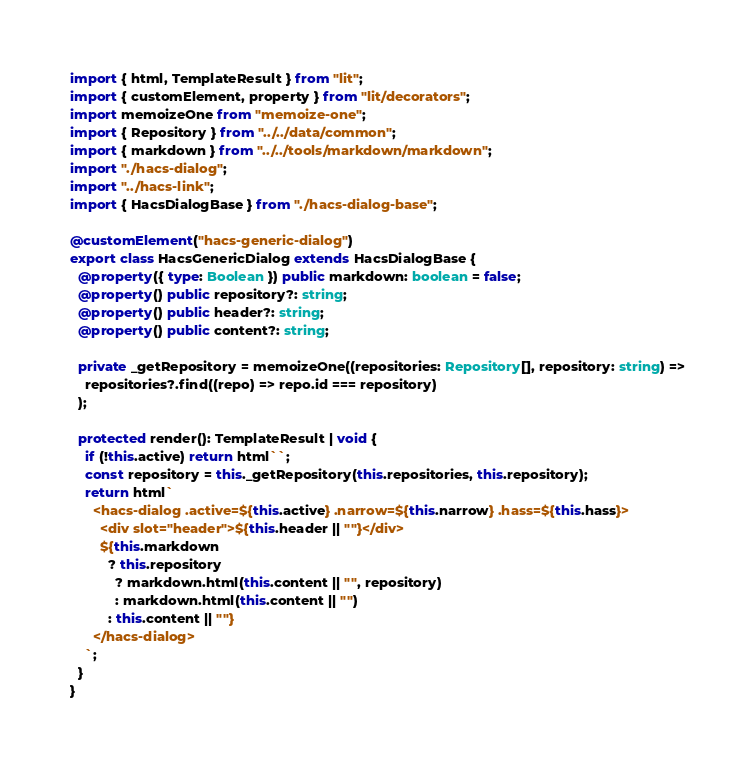<code> <loc_0><loc_0><loc_500><loc_500><_TypeScript_>import { html, TemplateResult } from "lit";
import { customElement, property } from "lit/decorators";
import memoizeOne from "memoize-one";
import { Repository } from "../../data/common";
import { markdown } from "../../tools/markdown/markdown";
import "./hacs-dialog";
import "../hacs-link";
import { HacsDialogBase } from "./hacs-dialog-base";

@customElement("hacs-generic-dialog")
export class HacsGenericDialog extends HacsDialogBase {
  @property({ type: Boolean }) public markdown: boolean = false;
  @property() public repository?: string;
  @property() public header?: string;
  @property() public content?: string;

  private _getRepository = memoizeOne((repositories: Repository[], repository: string) =>
    repositories?.find((repo) => repo.id === repository)
  );

  protected render(): TemplateResult | void {
    if (!this.active) return html``;
    const repository = this._getRepository(this.repositories, this.repository);
    return html`
      <hacs-dialog .active=${this.active} .narrow=${this.narrow} .hass=${this.hass}>
        <div slot="header">${this.header || ""}</div>
        ${this.markdown
          ? this.repository
            ? markdown.html(this.content || "", repository)
            : markdown.html(this.content || "")
          : this.content || ""}
      </hacs-dialog>
    `;
  }
}
</code> 